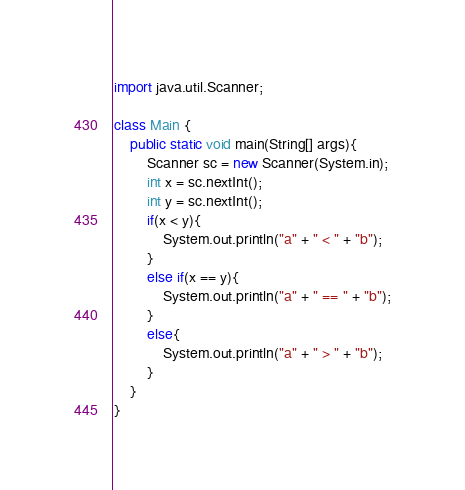<code> <loc_0><loc_0><loc_500><loc_500><_Java_>import java.util.Scanner;

class Main {
	public static void main(String[] args){
		Scanner sc = new Scanner(System.in);
		int x = sc.nextInt();
		int y = sc.nextInt();
		if(x < y){
			System.out.println("a" + " < " + "b");
		}
		else if(x == y){
			System.out.println("a" + " == " + "b");
		}
		else{
			System.out.println("a" + " > " + "b");
		}
	}
}</code> 